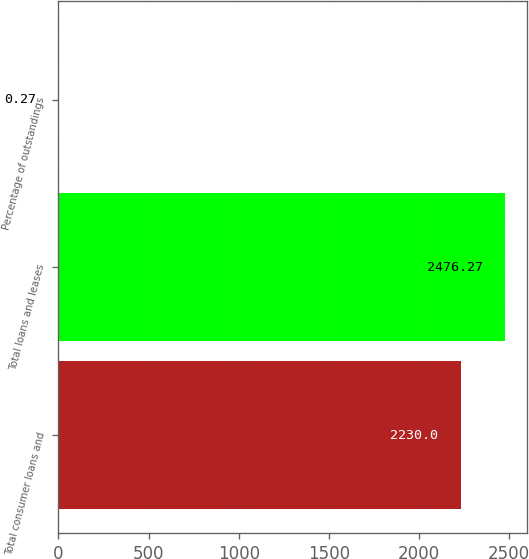Convert chart to OTSL. <chart><loc_0><loc_0><loc_500><loc_500><bar_chart><fcel>Total consumer loans and<fcel>Total loans and leases<fcel>Percentage of outstandings<nl><fcel>2230<fcel>2476.27<fcel>0.27<nl></chart> 